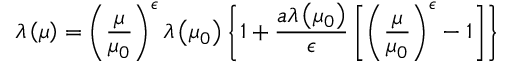<formula> <loc_0><loc_0><loc_500><loc_500>\lambda \left ( \mu \right ) = \left ( \frac { \mu } { \mu _ { 0 } } \right ) ^ { \epsilon } \lambda \left ( \mu _ { 0 } \right ) \left \{ 1 + \frac { a \lambda \left ( \mu _ { 0 } \right ) } { \epsilon } \left [ \left ( \frac { \mu } { \mu _ { 0 } } \right ) ^ { \epsilon } - 1 \right ] \right \}</formula> 